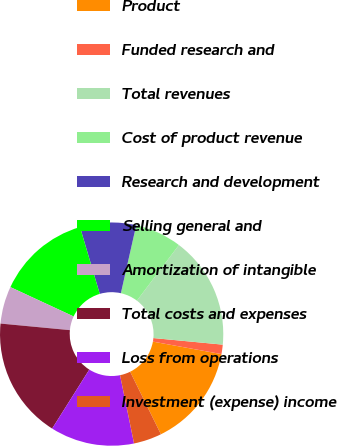Convert chart to OTSL. <chart><loc_0><loc_0><loc_500><loc_500><pie_chart><fcel>Product<fcel>Funded research and<fcel>Total revenues<fcel>Cost of product revenue<fcel>Research and development<fcel>Selling general and<fcel>Amortization of intangible<fcel>Total costs and expenses<fcel>Loss from operations<fcel>Investment (expense) income<nl><fcel>14.86%<fcel>1.36%<fcel>16.21%<fcel>6.76%<fcel>8.11%<fcel>13.51%<fcel>5.41%<fcel>17.56%<fcel>12.16%<fcel>4.06%<nl></chart> 